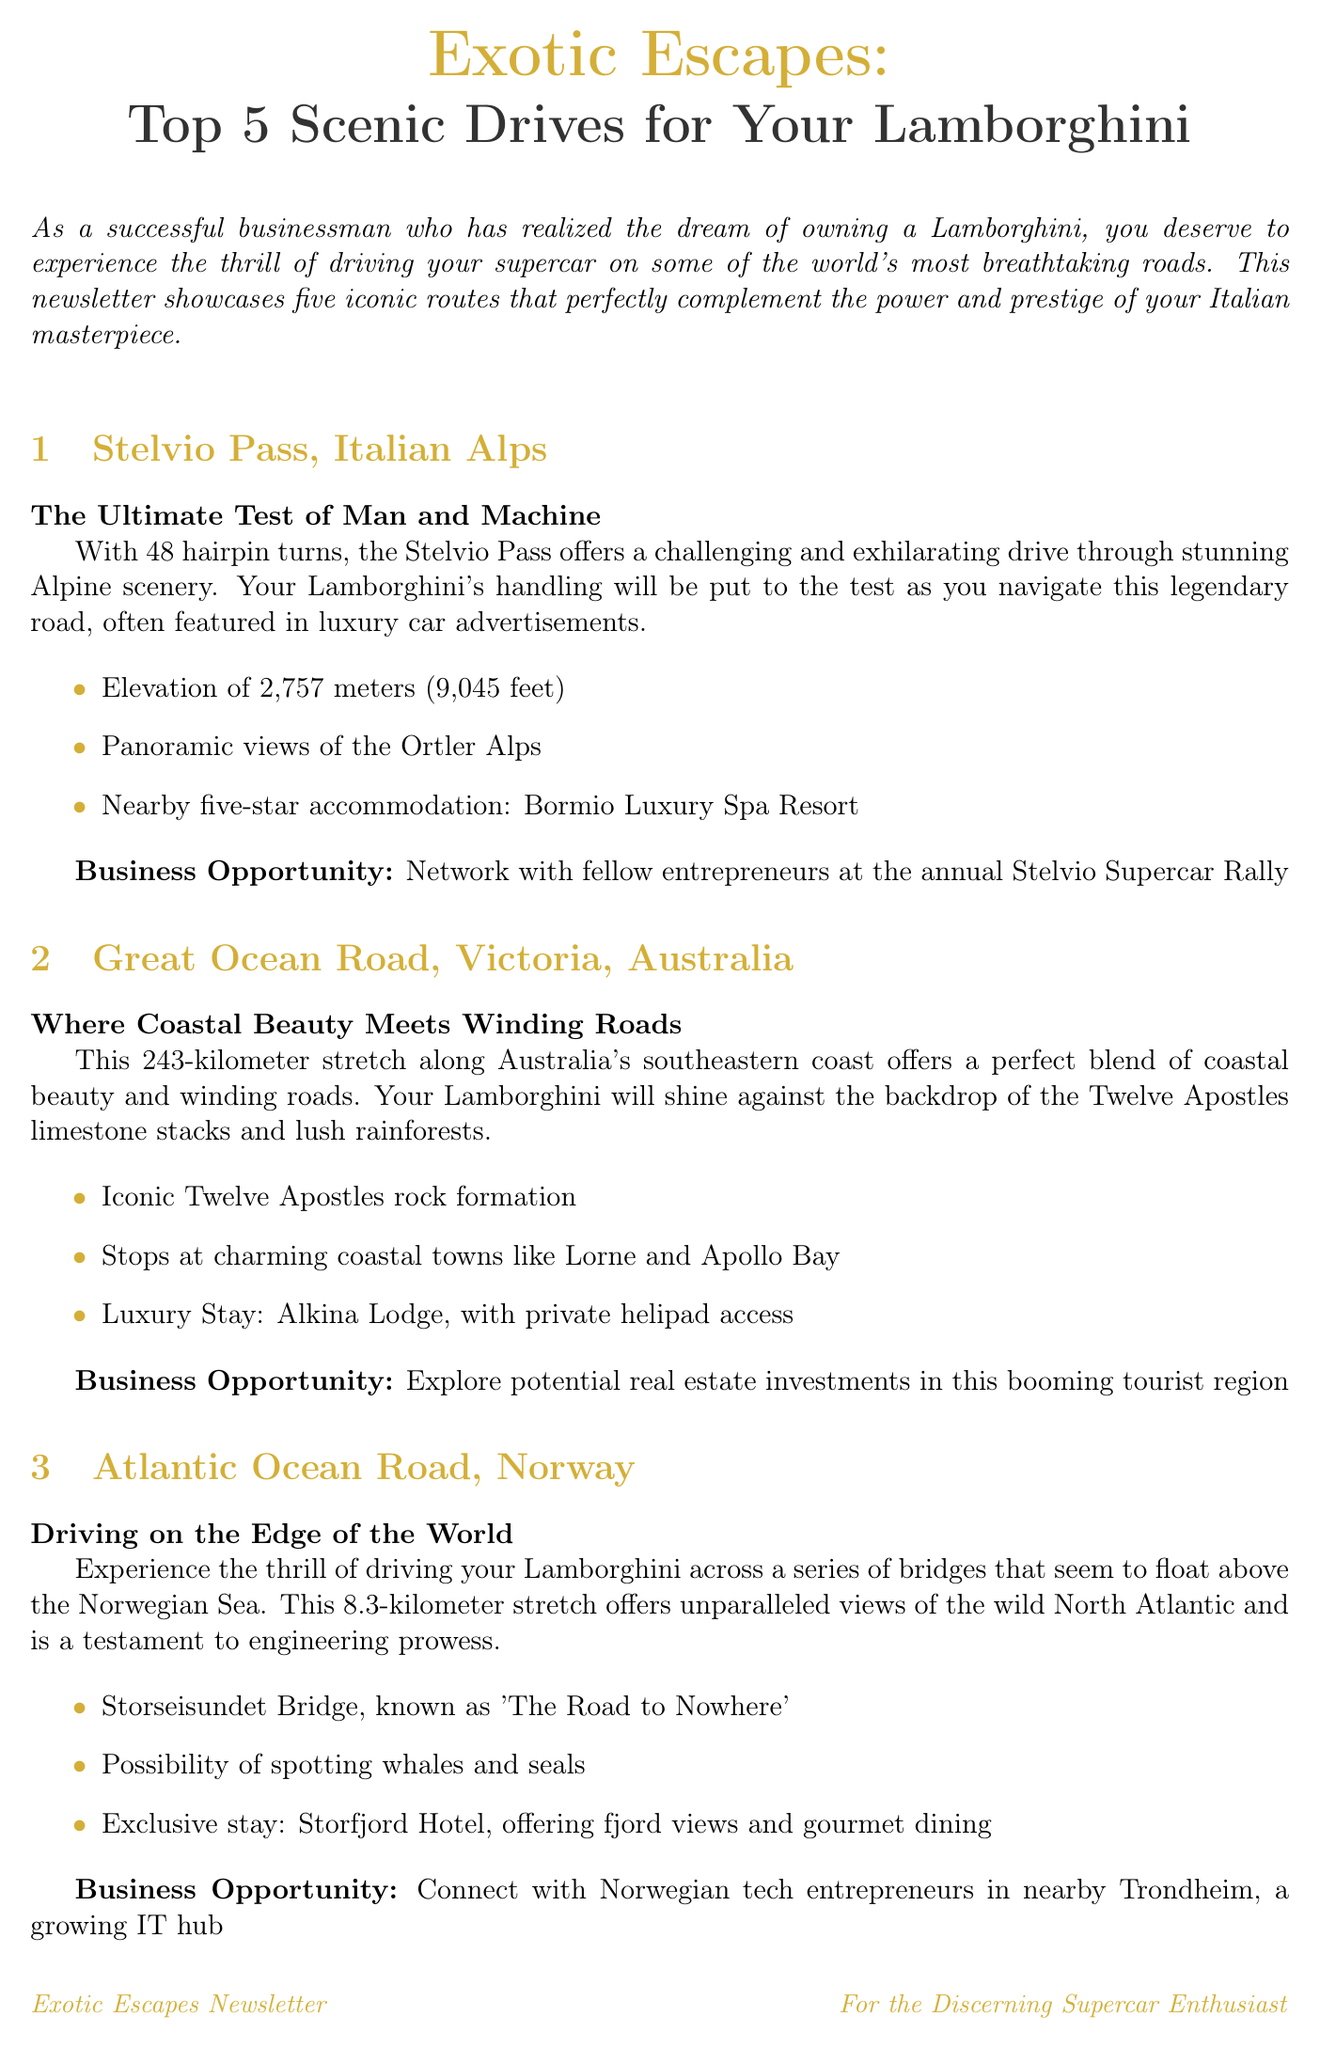what is the title of the newsletter? The title of the newsletter is stated at the beginning of the document.
Answer: Exotic Escapes: Top 5 Scenic Drives for Your Lamborghini how many hairpin turns does the Stelvio Pass have? The Stelvio Pass is described to have 48 hairpin turns in the document.
Answer: 48 what is the luxury accommodation mentioned for the Great Ocean Road? The document specifies the luxury stay for the Great Ocean Road.
Answer: Alkina Lodge which bridge is known as "The Road to Nowhere"? The Atlantic Ocean Road features Storseisundet Bridge, known by this name.
Answer: Storseisundet Bridge what is the elevation of the Furka Pass? The document provides the elevation of the Furka Pass in meters and feet.
Answer: 2,429 meters (7,969 feet) what type of dining experience can be found at the Storfjord Hotel? The Storfjord Hotel is mentioned in the document as providing a specific dining experience.
Answer: gourmet dining which route is described as the "Ultimate Californian Dream Drive"? The description for the Pacific Coast Highway includes this phrase.
Answer: Pacific Coast Highway what is the name of the luxury accommodation at the Pacific Coast Highway? The document highlights a specific accommodation for this route.
Answer: Post Ranch Inn what business opportunity is mentioned for the Stelvio Pass? The document notes a specific networking event in relation to the Stelvio Pass.
Answer: Stelvio Supercar Rally 